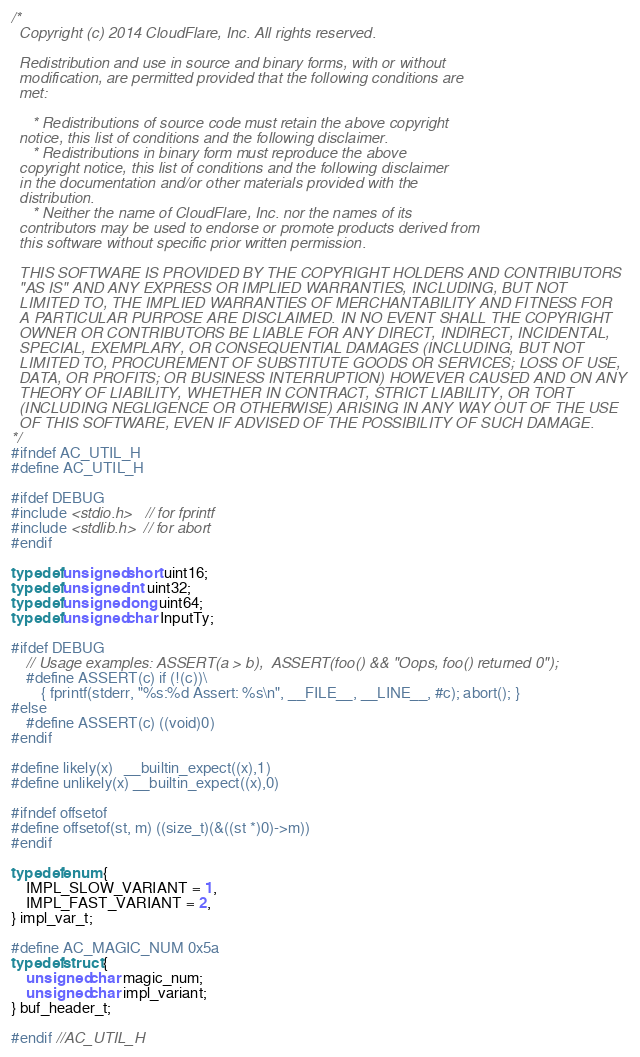Convert code to text. <code><loc_0><loc_0><loc_500><loc_500><_C++_>/*
  Copyright (c) 2014 CloudFlare, Inc. All rights reserved.

  Redistribution and use in source and binary forms, with or without
  modification, are permitted provided that the following conditions are
  met:

     * Redistributions of source code must retain the above copyright
  notice, this list of conditions and the following disclaimer.
     * Redistributions in binary form must reproduce the above
  copyright notice, this list of conditions and the following disclaimer
  in the documentation and/or other materials provided with the
  distribution.
     * Neither the name of CloudFlare, Inc. nor the names of its
  contributors may be used to endorse or promote products derived from
  this software without specific prior written permission.

  THIS SOFTWARE IS PROVIDED BY THE COPYRIGHT HOLDERS AND CONTRIBUTORS
  "AS IS" AND ANY EXPRESS OR IMPLIED WARRANTIES, INCLUDING, BUT NOT
  LIMITED TO, THE IMPLIED WARRANTIES OF MERCHANTABILITY AND FITNESS FOR
  A PARTICULAR PURPOSE ARE DISCLAIMED. IN NO EVENT SHALL THE COPYRIGHT
  OWNER OR CONTRIBUTORS BE LIABLE FOR ANY DIRECT, INDIRECT, INCIDENTAL,
  SPECIAL, EXEMPLARY, OR CONSEQUENTIAL DAMAGES (INCLUDING, BUT NOT
  LIMITED TO, PROCUREMENT OF SUBSTITUTE GOODS OR SERVICES; LOSS OF USE,
  DATA, OR PROFITS; OR BUSINESS INTERRUPTION) HOWEVER CAUSED AND ON ANY
  THEORY OF LIABILITY, WHETHER IN CONTRACT, STRICT LIABILITY, OR TORT
  (INCLUDING NEGLIGENCE OR OTHERWISE) ARISING IN ANY WAY OUT OF THE USE
  OF THIS SOFTWARE, EVEN IF ADVISED OF THE POSSIBILITY OF SUCH DAMAGE.
*/
#ifndef AC_UTIL_H
#define AC_UTIL_H

#ifdef DEBUG
#include <stdio.h>   // for fprintf
#include <stdlib.h>  // for abort
#endif

typedef unsigned short uint16;
typedef unsigned int uint32;
typedef unsigned long uint64;
typedef unsigned char InputTy;

#ifdef DEBUG
    // Usage examples: ASSERT(a > b),  ASSERT(foo() && "Oops, foo() returned 0");
    #define ASSERT(c) if (!(c))\
        { fprintf(stderr, "%s:%d Assert: %s\n", __FILE__, __LINE__, #c); abort(); }
#else
    #define ASSERT(c) ((void)0)
#endif

#define likely(x)   __builtin_expect((x),1)
#define unlikely(x) __builtin_expect((x),0)

#ifndef offsetof
#define offsetof(st, m) ((size_t)(&((st *)0)->m))
#endif

typedef enum {
    IMPL_SLOW_VARIANT = 1,
    IMPL_FAST_VARIANT = 2,
} impl_var_t;

#define AC_MAGIC_NUM 0x5a
typedef struct {
    unsigned char magic_num;
    unsigned char impl_variant;
} buf_header_t;

#endif //AC_UTIL_H
</code> 